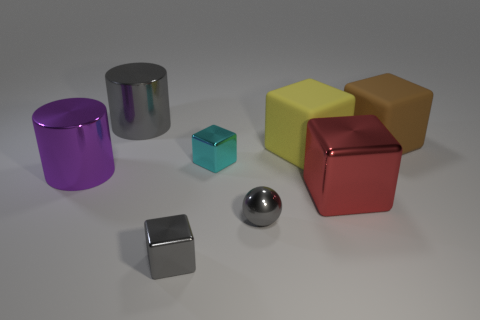What color is the other rubber thing that is the same shape as the yellow rubber thing?
Give a very brief answer. Brown. There is a metal block in front of the gray shiny sphere; is it the same size as the gray shiny ball?
Provide a succinct answer. Yes. Is the number of gray shiny spheres that are behind the metal ball less than the number of tiny yellow shiny cylinders?
Give a very brief answer. No. Is there anything else that has the same size as the gray metal cylinder?
Give a very brief answer. Yes. What size is the matte thing that is on the left side of the large block that is in front of the big yellow cube?
Provide a succinct answer. Large. Are there any other things that are the same shape as the cyan shiny object?
Your response must be concise. Yes. Is the number of gray balls less than the number of matte objects?
Your answer should be very brief. Yes. There is a cube that is in front of the big purple cylinder and right of the cyan block; what is it made of?
Offer a terse response. Metal. There is a small metal thing that is behind the gray shiny ball; is there a red shiny object behind it?
Make the answer very short. No. How many things are either big purple spheres or big rubber objects?
Ensure brevity in your answer.  2. 